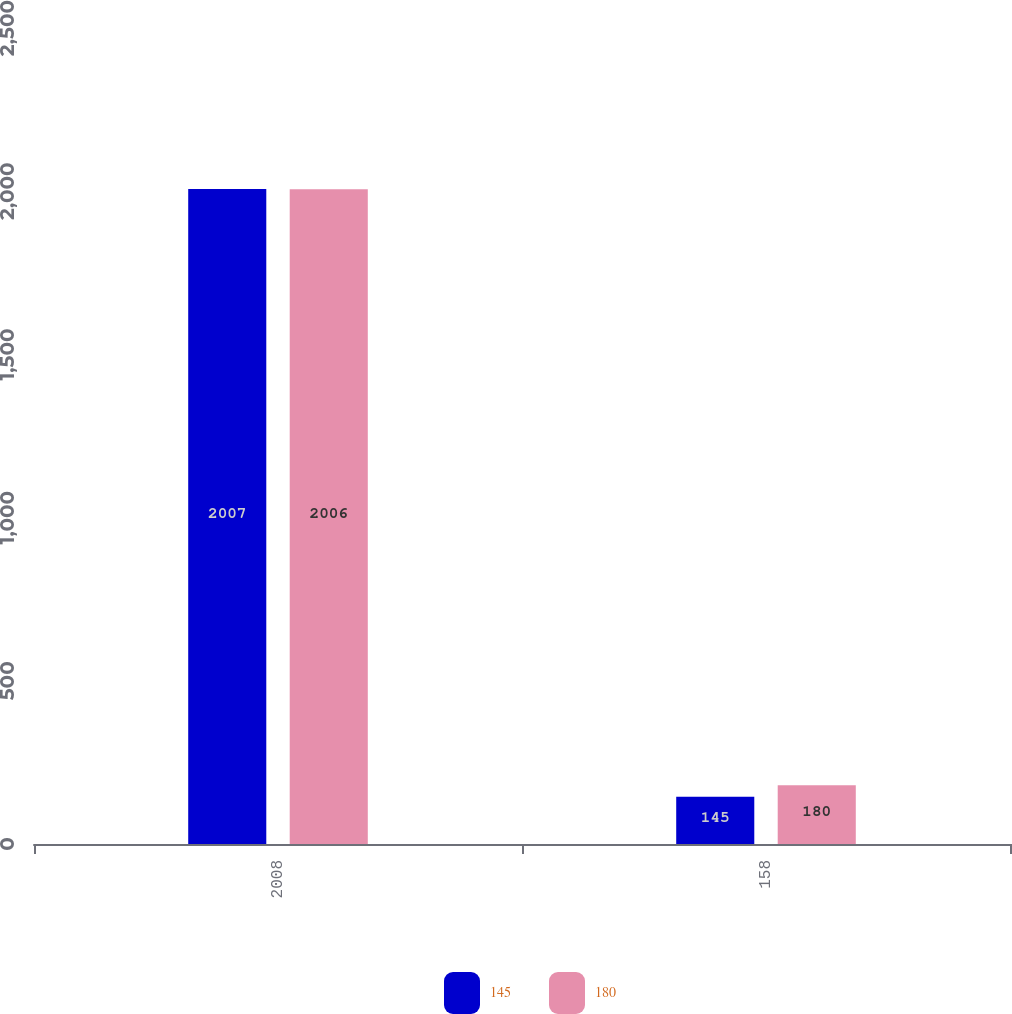Convert chart. <chart><loc_0><loc_0><loc_500><loc_500><stacked_bar_chart><ecel><fcel>2008<fcel>158<nl><fcel>145<fcel>2007<fcel>145<nl><fcel>180<fcel>2006<fcel>180<nl></chart> 